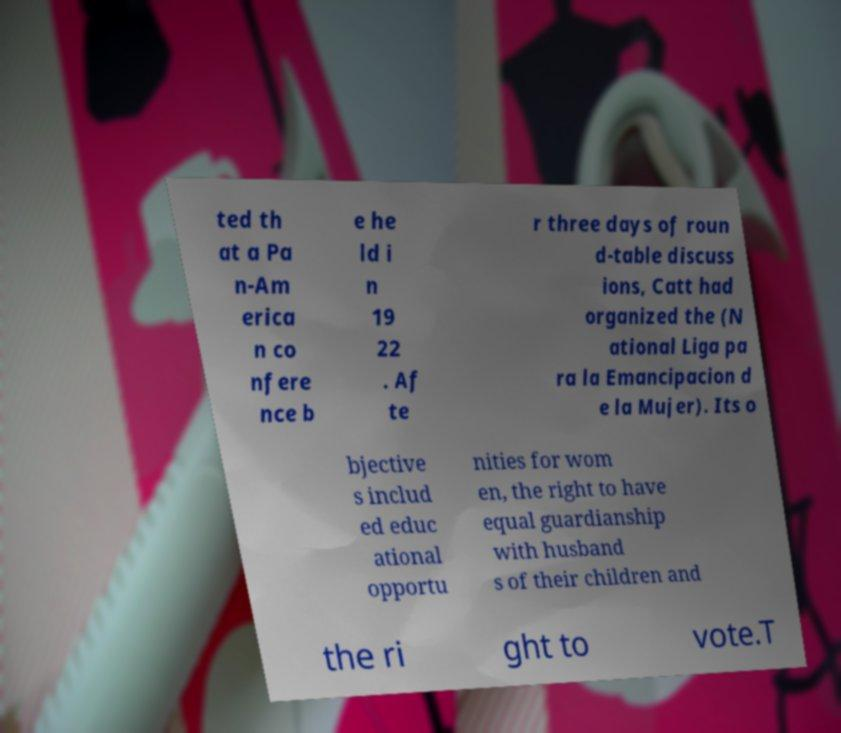Please read and relay the text visible in this image. What does it say? ted th at a Pa n-Am erica n co nfere nce b e he ld i n 19 22 . Af te r three days of roun d-table discuss ions, Catt had organized the (N ational Liga pa ra la Emancipacion d e la Mujer). Its o bjective s includ ed educ ational opportu nities for wom en, the right to have equal guardianship with husband s of their children and the ri ght to vote.T 